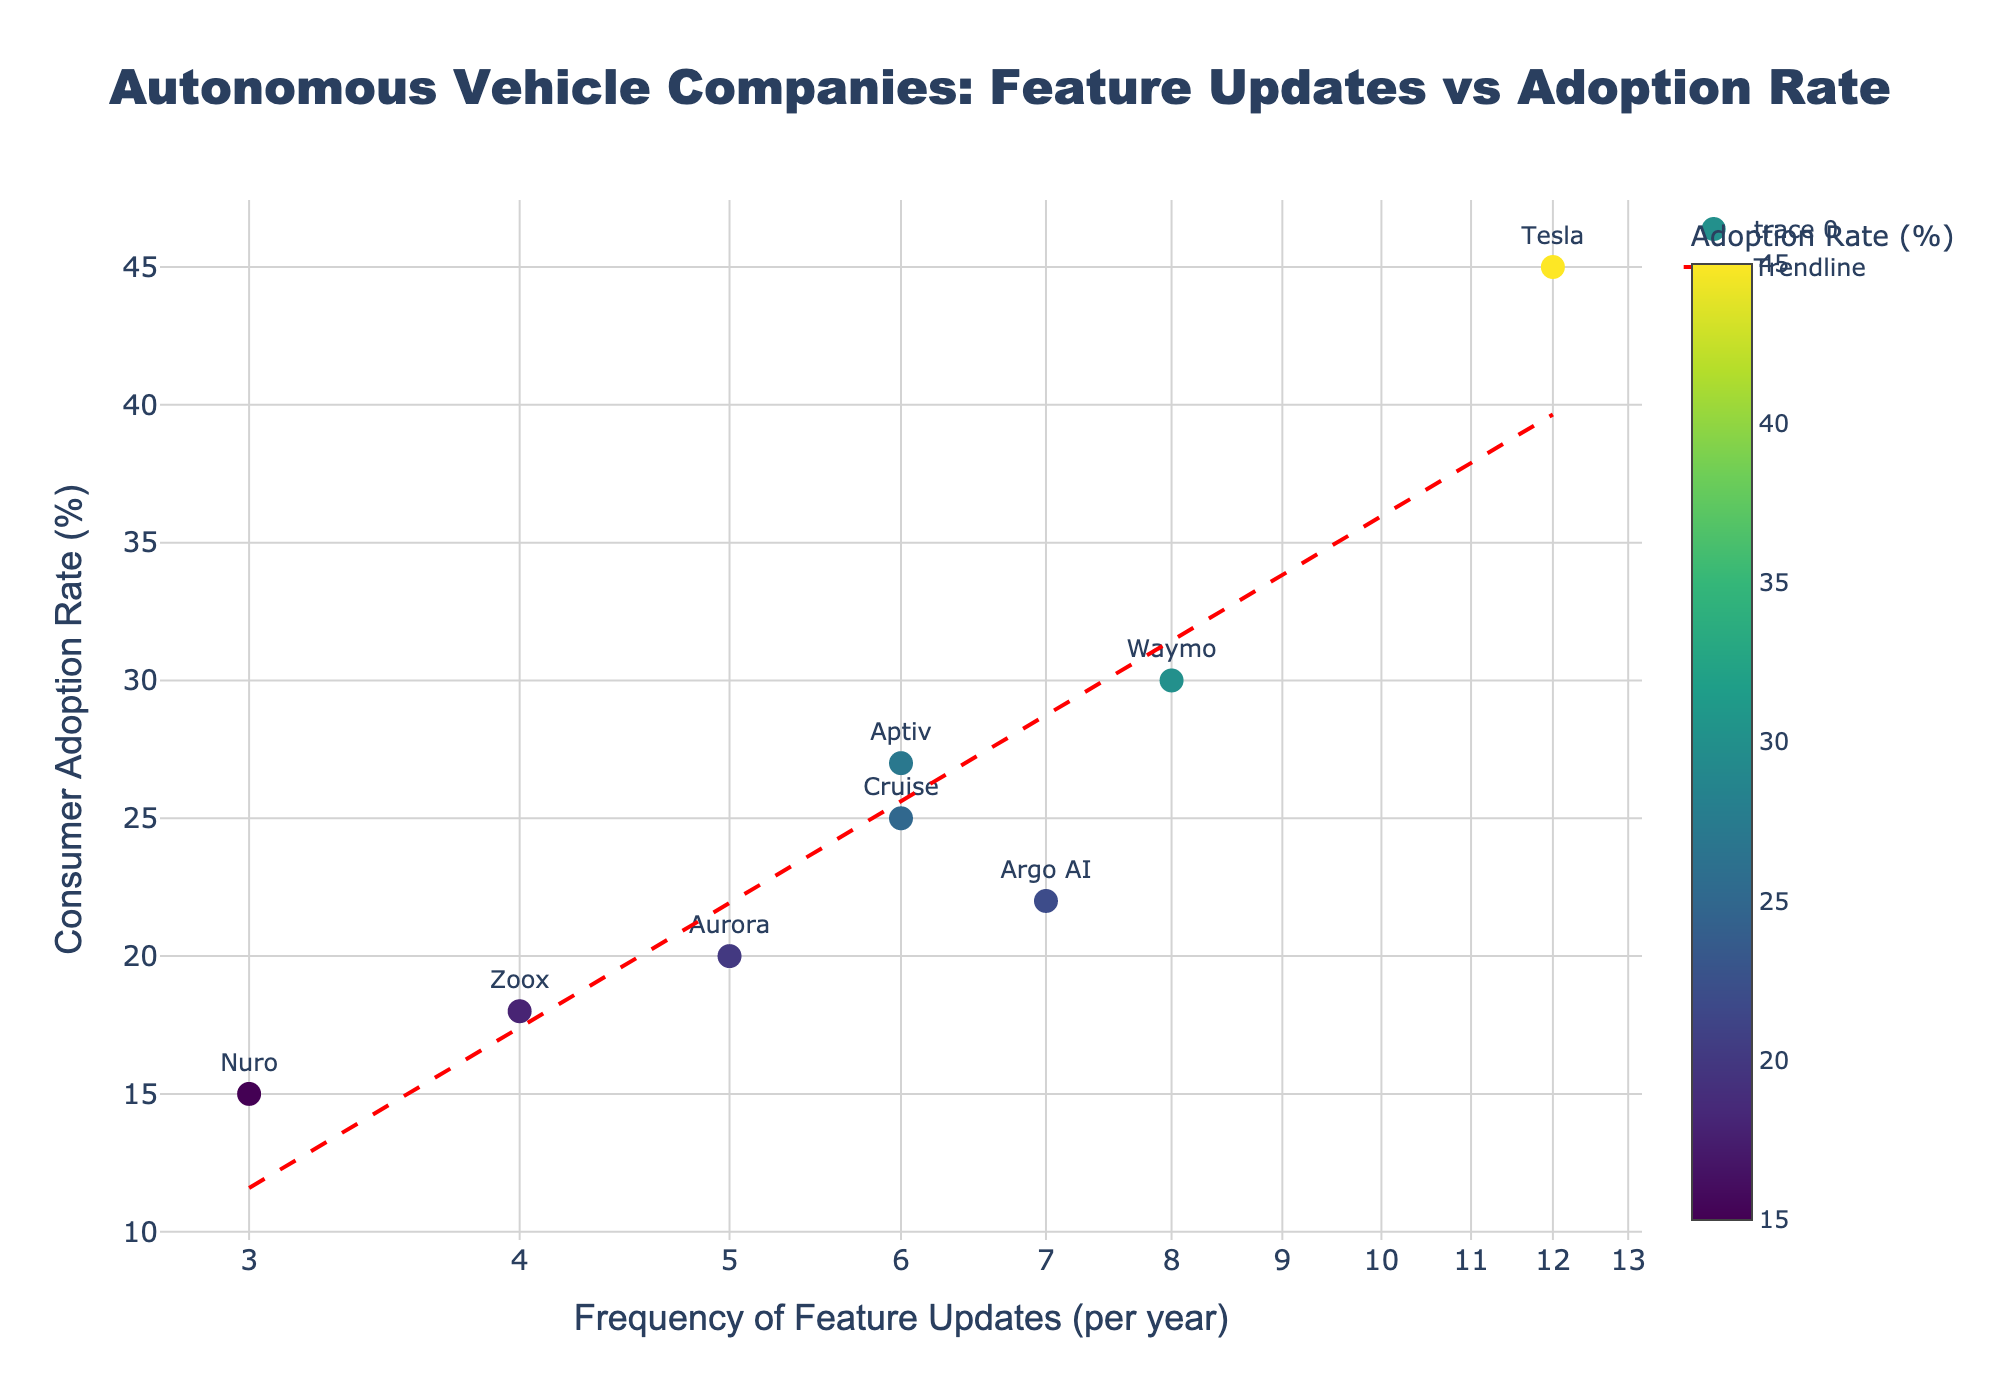What is the title of the scatter plot? The title of the scatter plot is located at the top and it helps to understand what the figure is about.
Answer: Autonomous Vehicle Companies: Feature Updates vs Adoption Rate Which company has the highest frequency of feature updates per year? By looking at the x-axis which represents the frequency of feature updates, the company with the data point furthest to the right is identifiable.
Answer: Tesla What is the consumer adoption rate of Waymo? Locate Waymo on the scatter plot by the label and move vertically to the y-axis to find the corresponding value.
Answer: 30% How many companies have a consumer adoption rate greater than 25%? Count the number of data points above the 25% mark on the y-axis.
Answer: 4 What is the median frequency of feature updates per year, and which company represents it? List the frequencies: [3, 4, 5, 6, 6, 7, 8, 12], find the middle values (6 and 6), and identify a company with one of these values.
Answer: 6, Cruise or Aptiv Which company shows the lowest consumer adoption rate? Identify the data point lowest on the y-axis, which corresponds to the consumer adoption rate.
Answer: Nuro What is the log-scaled x-axis used to represent in this plot? Understand the log-scaled x-axis by recognizing the axis and how it transforms linear distributions.
Answer: Frequency of Feature Updates (per year) How does the trendline in the plot help interpret the data? Analyze how the red dashed trendline indicates the relationship between the frequency of updates and the adoption rate.
Answer: It shows a positive correlation Compare the consumer adoption rates of Argo AI and Aptiv. Which is higher and by how much? Identify the y-axis positions of Argo AI and Aptiv and calculate the difference in their adoption rates.
Answer: Aptiv’s is higher by 5% Which company has the least frequency of feature updates, and what is its adoption rate? Locate the company furthest to the left on the x-axis and read its corresponding y-axis value.
Answer: Nuro, 15% 